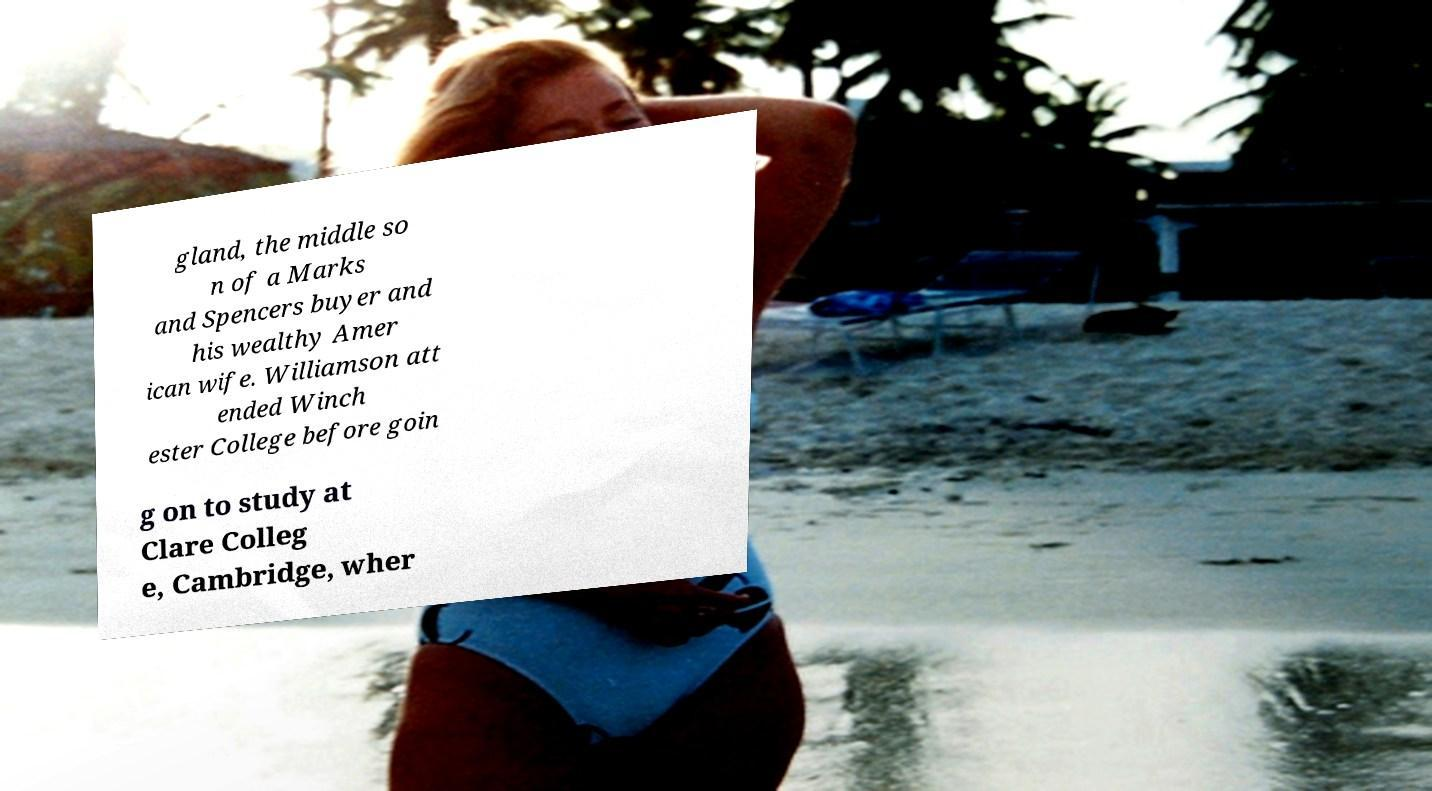Can you accurately transcribe the text from the provided image for me? gland, the middle so n of a Marks and Spencers buyer and his wealthy Amer ican wife. Williamson att ended Winch ester College before goin g on to study at Clare Colleg e, Cambridge, wher 